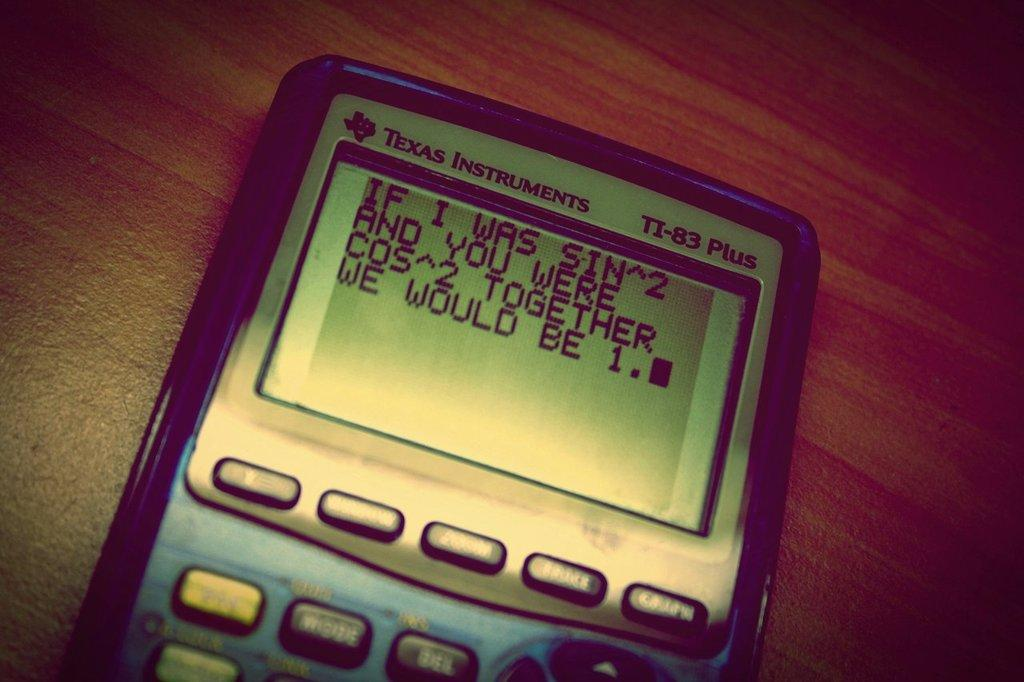<image>
Describe the image concisely. A Texas Instrument TI-83 Plus calculator with a message on the screen. 